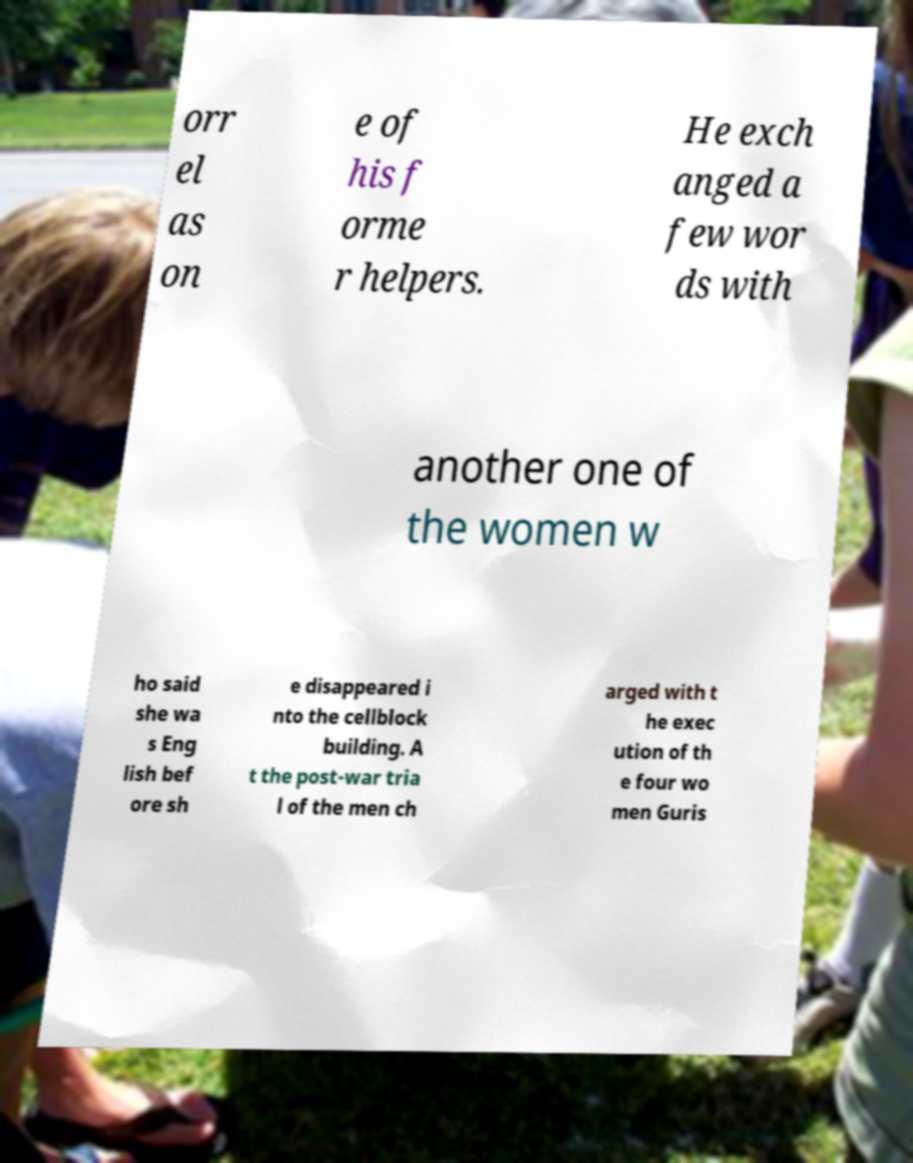For documentation purposes, I need the text within this image transcribed. Could you provide that? orr el as on e of his f orme r helpers. He exch anged a few wor ds with another one of the women w ho said she wa s Eng lish bef ore sh e disappeared i nto the cellblock building. A t the post-war tria l of the men ch arged with t he exec ution of th e four wo men Guris 